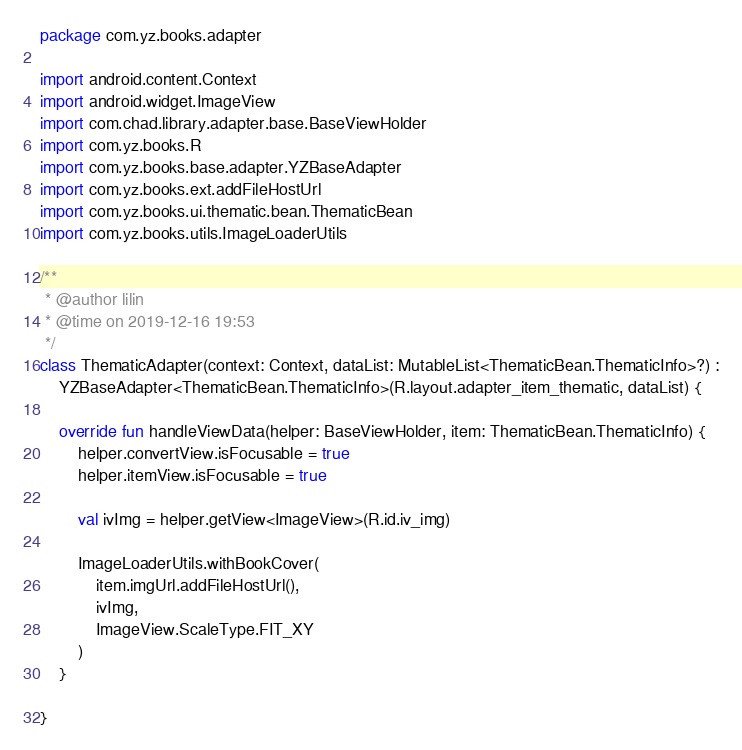<code> <loc_0><loc_0><loc_500><loc_500><_Kotlin_>package com.yz.books.adapter

import android.content.Context
import android.widget.ImageView
import com.chad.library.adapter.base.BaseViewHolder
import com.yz.books.R
import com.yz.books.base.adapter.YZBaseAdapter
import com.yz.books.ext.addFileHostUrl
import com.yz.books.ui.thematic.bean.ThematicBean
import com.yz.books.utils.ImageLoaderUtils

/**
 * @author lilin
 * @time on 2019-12-16 19:53
 */
class ThematicAdapter(context: Context, dataList: MutableList<ThematicBean.ThematicInfo>?) :
    YZBaseAdapter<ThematicBean.ThematicInfo>(R.layout.adapter_item_thematic, dataList) {

    override fun handleViewData(helper: BaseViewHolder, item: ThematicBean.ThematicInfo) {
        helper.convertView.isFocusable = true
        helper.itemView.isFocusable = true

        val ivImg = helper.getView<ImageView>(R.id.iv_img)

        ImageLoaderUtils.withBookCover(
            item.imgUrl.addFileHostUrl(),
            ivImg,
            ImageView.ScaleType.FIT_XY
        )
    }

}</code> 